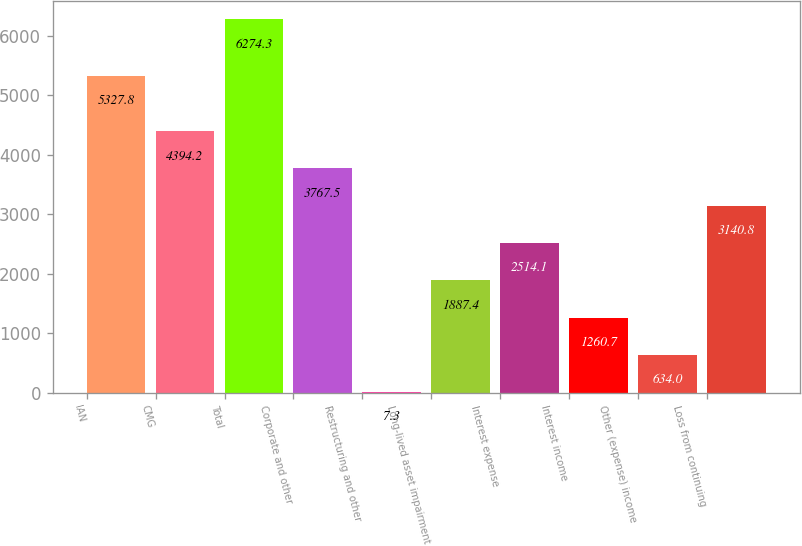<chart> <loc_0><loc_0><loc_500><loc_500><bar_chart><fcel>IAN<fcel>CMG<fcel>Total<fcel>Corporate and other<fcel>Restructuring and other<fcel>Long-lived asset impairment<fcel>Interest expense<fcel>Interest income<fcel>Other (expense) income<fcel>Loss from continuing<nl><fcel>5327.8<fcel>4394.2<fcel>6274.3<fcel>3767.5<fcel>7.3<fcel>1887.4<fcel>2514.1<fcel>1260.7<fcel>634<fcel>3140.8<nl></chart> 